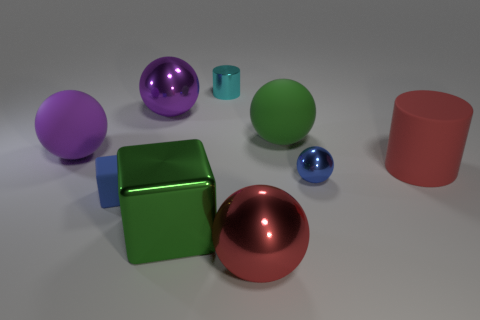What is the shape of the small blue rubber object?
Offer a terse response. Cube. There is a big thing that is right of the big green matte thing; is it the same color as the shiny sphere that is left of the red metallic thing?
Offer a very short reply. No. Do the cyan thing and the purple matte object have the same shape?
Offer a terse response. No. Are there any other things that are the same shape as the cyan thing?
Your answer should be compact. Yes. Are the red thing left of the rubber cylinder and the large green sphere made of the same material?
Keep it short and to the point. No. What shape is the matte object that is behind the blue metallic object and to the left of the big green ball?
Your response must be concise. Sphere. There is a green object that is in front of the tiny blue shiny object; is there a block that is to the left of it?
Give a very brief answer. Yes. How many other things are there of the same material as the large green cube?
Your answer should be compact. 4. There is a big matte object that is in front of the large purple rubber sphere; does it have the same shape as the matte object that is on the left side of the blue matte thing?
Your answer should be very brief. No. Is the material of the large green block the same as the green sphere?
Offer a very short reply. No. 